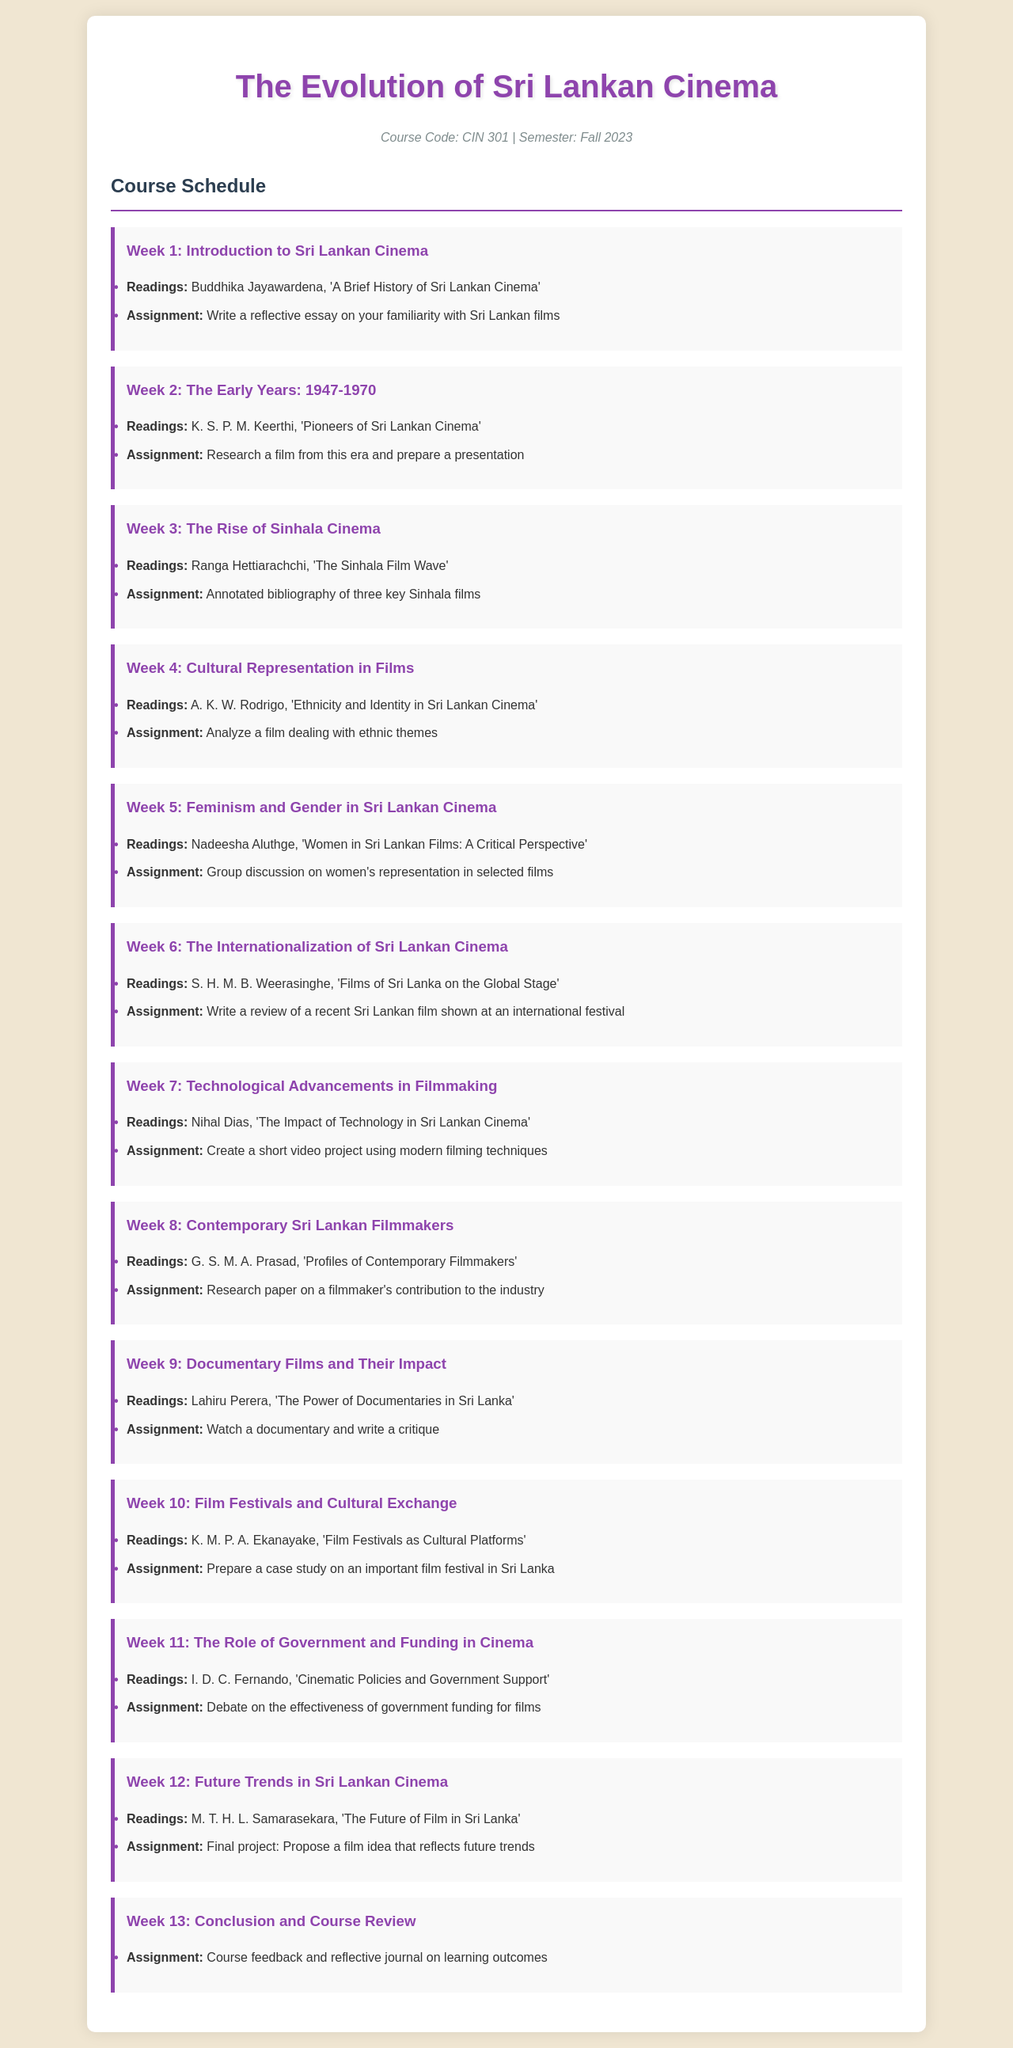What is the course code? The course code is explicitly stated at the beginning of the document, which is CIN 301.
Answer: CIN 301 What is the title of the first reading? The first reading is listed under Week 1, which is 'A Brief History of Sri Lankan Cinema' by Buddhika Jayawardena.
Answer: A Brief History of Sri Lankan Cinema How many weeks are covered in the course schedule? The document outlines a total of thirteen weeks in the course schedule.
Answer: 13 What is the assignment for Week 6? The assignment for Week 6 requires writing a review of a recent Sri Lankan film shown at an international festival.
Answer: Write a review of a recent Sri Lankan film shown at an international festival Which week focuses on the role of government in cinema? The role of government and funding in cinema is covered in Week 11.
Answer: Week 11 What theme is explored in Week 4's readings? The readings for Week 4 explore the theme of ethnicity and identity in Sri Lankan cinema.
Answer: Ethnicity and Identity What is the major task for the final project in Week 12? The final project in Week 12 involves proposing a film idea that reflects future trends.
Answer: Propose a film idea that reflects future trends Who is the author of the reading for Week 5? The reading for Week 5 is authored by Nadeesha Aluthge.
Answer: Nadeesha Aluthge What type of film does the Week 9 assignment refer to? The Week 9 assignment refers to a documentary film that students need to critique.
Answer: A documentary film 